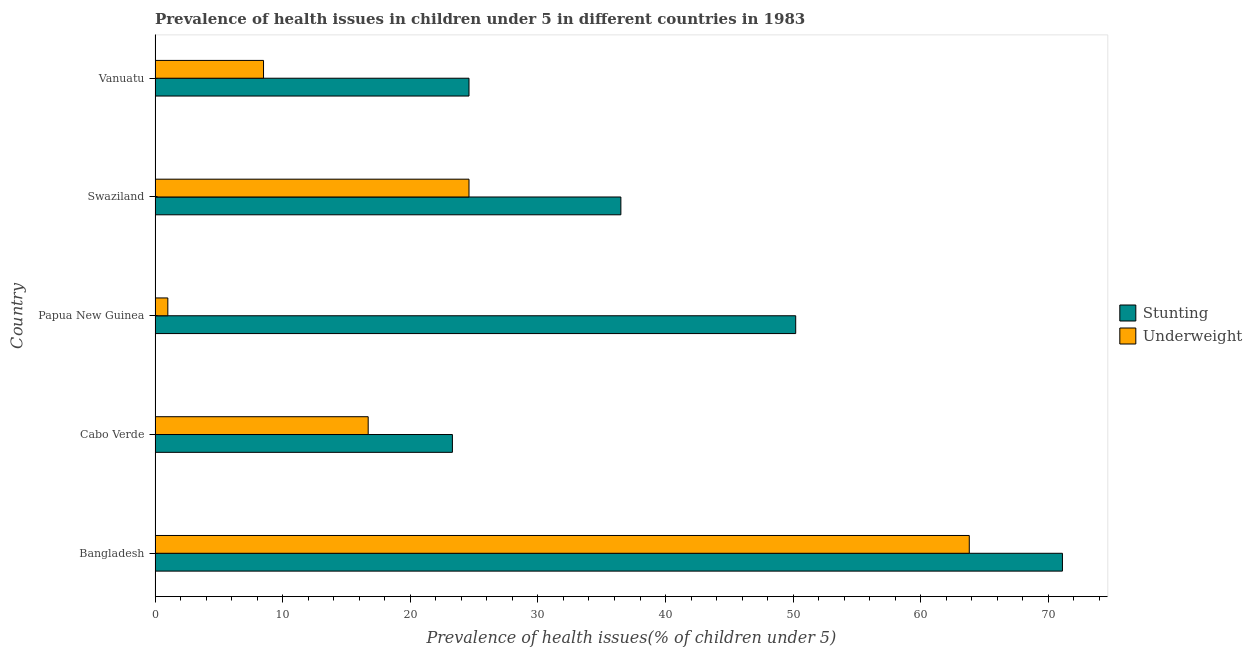How many different coloured bars are there?
Provide a short and direct response. 2. Are the number of bars per tick equal to the number of legend labels?
Make the answer very short. Yes. How many bars are there on the 4th tick from the bottom?
Make the answer very short. 2. What is the label of the 3rd group of bars from the top?
Provide a succinct answer. Papua New Guinea. What is the percentage of stunted children in Vanuatu?
Provide a succinct answer. 24.6. Across all countries, what is the maximum percentage of stunted children?
Your answer should be very brief. 71.1. Across all countries, what is the minimum percentage of stunted children?
Give a very brief answer. 23.3. In which country was the percentage of stunted children maximum?
Give a very brief answer. Bangladesh. In which country was the percentage of underweight children minimum?
Offer a very short reply. Papua New Guinea. What is the total percentage of stunted children in the graph?
Your answer should be very brief. 205.7. What is the difference between the percentage of underweight children in Bangladesh and that in Papua New Guinea?
Provide a short and direct response. 62.8. What is the difference between the percentage of stunted children in Swaziland and the percentage of underweight children in Cabo Verde?
Offer a terse response. 19.8. What is the average percentage of stunted children per country?
Your answer should be very brief. 41.14. What is the ratio of the percentage of stunted children in Bangladesh to that in Vanuatu?
Provide a short and direct response. 2.89. What is the difference between the highest and the second highest percentage of stunted children?
Make the answer very short. 20.9. What is the difference between the highest and the lowest percentage of underweight children?
Give a very brief answer. 62.8. What does the 1st bar from the top in Cabo Verde represents?
Give a very brief answer. Underweight. What does the 2nd bar from the bottom in Cabo Verde represents?
Give a very brief answer. Underweight. Does the graph contain any zero values?
Give a very brief answer. No. Does the graph contain grids?
Ensure brevity in your answer.  No. Where does the legend appear in the graph?
Provide a short and direct response. Center right. How many legend labels are there?
Provide a succinct answer. 2. What is the title of the graph?
Provide a short and direct response. Prevalence of health issues in children under 5 in different countries in 1983. Does "Birth rate" appear as one of the legend labels in the graph?
Ensure brevity in your answer.  No. What is the label or title of the X-axis?
Your answer should be compact. Prevalence of health issues(% of children under 5). What is the Prevalence of health issues(% of children under 5) in Stunting in Bangladesh?
Provide a succinct answer. 71.1. What is the Prevalence of health issues(% of children under 5) in Underweight in Bangladesh?
Keep it short and to the point. 63.8. What is the Prevalence of health issues(% of children under 5) in Stunting in Cabo Verde?
Provide a short and direct response. 23.3. What is the Prevalence of health issues(% of children under 5) in Underweight in Cabo Verde?
Offer a very short reply. 16.7. What is the Prevalence of health issues(% of children under 5) of Stunting in Papua New Guinea?
Give a very brief answer. 50.2. What is the Prevalence of health issues(% of children under 5) in Stunting in Swaziland?
Provide a short and direct response. 36.5. What is the Prevalence of health issues(% of children under 5) in Underweight in Swaziland?
Provide a succinct answer. 24.6. What is the Prevalence of health issues(% of children under 5) of Stunting in Vanuatu?
Keep it short and to the point. 24.6. Across all countries, what is the maximum Prevalence of health issues(% of children under 5) in Stunting?
Provide a succinct answer. 71.1. Across all countries, what is the maximum Prevalence of health issues(% of children under 5) of Underweight?
Keep it short and to the point. 63.8. Across all countries, what is the minimum Prevalence of health issues(% of children under 5) in Stunting?
Provide a succinct answer. 23.3. Across all countries, what is the minimum Prevalence of health issues(% of children under 5) in Underweight?
Ensure brevity in your answer.  1. What is the total Prevalence of health issues(% of children under 5) in Stunting in the graph?
Offer a terse response. 205.7. What is the total Prevalence of health issues(% of children under 5) of Underweight in the graph?
Keep it short and to the point. 114.6. What is the difference between the Prevalence of health issues(% of children under 5) of Stunting in Bangladesh and that in Cabo Verde?
Provide a succinct answer. 47.8. What is the difference between the Prevalence of health issues(% of children under 5) in Underweight in Bangladesh and that in Cabo Verde?
Give a very brief answer. 47.1. What is the difference between the Prevalence of health issues(% of children under 5) of Stunting in Bangladesh and that in Papua New Guinea?
Provide a succinct answer. 20.9. What is the difference between the Prevalence of health issues(% of children under 5) of Underweight in Bangladesh and that in Papua New Guinea?
Offer a very short reply. 62.8. What is the difference between the Prevalence of health issues(% of children under 5) of Stunting in Bangladesh and that in Swaziland?
Your answer should be compact. 34.6. What is the difference between the Prevalence of health issues(% of children under 5) of Underweight in Bangladesh and that in Swaziland?
Provide a succinct answer. 39.2. What is the difference between the Prevalence of health issues(% of children under 5) of Stunting in Bangladesh and that in Vanuatu?
Your response must be concise. 46.5. What is the difference between the Prevalence of health issues(% of children under 5) in Underweight in Bangladesh and that in Vanuatu?
Offer a very short reply. 55.3. What is the difference between the Prevalence of health issues(% of children under 5) in Stunting in Cabo Verde and that in Papua New Guinea?
Make the answer very short. -26.9. What is the difference between the Prevalence of health issues(% of children under 5) of Underweight in Cabo Verde and that in Papua New Guinea?
Ensure brevity in your answer.  15.7. What is the difference between the Prevalence of health issues(% of children under 5) in Stunting in Cabo Verde and that in Swaziland?
Ensure brevity in your answer.  -13.2. What is the difference between the Prevalence of health issues(% of children under 5) of Underweight in Cabo Verde and that in Swaziland?
Your answer should be compact. -7.9. What is the difference between the Prevalence of health issues(% of children under 5) of Stunting in Cabo Verde and that in Vanuatu?
Offer a very short reply. -1.3. What is the difference between the Prevalence of health issues(% of children under 5) of Underweight in Papua New Guinea and that in Swaziland?
Provide a short and direct response. -23.6. What is the difference between the Prevalence of health issues(% of children under 5) in Stunting in Papua New Guinea and that in Vanuatu?
Your answer should be compact. 25.6. What is the difference between the Prevalence of health issues(% of children under 5) of Underweight in Papua New Guinea and that in Vanuatu?
Your answer should be compact. -7.5. What is the difference between the Prevalence of health issues(% of children under 5) of Stunting in Swaziland and that in Vanuatu?
Offer a very short reply. 11.9. What is the difference between the Prevalence of health issues(% of children under 5) of Underweight in Swaziland and that in Vanuatu?
Give a very brief answer. 16.1. What is the difference between the Prevalence of health issues(% of children under 5) of Stunting in Bangladesh and the Prevalence of health issues(% of children under 5) of Underweight in Cabo Verde?
Keep it short and to the point. 54.4. What is the difference between the Prevalence of health issues(% of children under 5) of Stunting in Bangladesh and the Prevalence of health issues(% of children under 5) of Underweight in Papua New Guinea?
Offer a terse response. 70.1. What is the difference between the Prevalence of health issues(% of children under 5) of Stunting in Bangladesh and the Prevalence of health issues(% of children under 5) of Underweight in Swaziland?
Offer a very short reply. 46.5. What is the difference between the Prevalence of health issues(% of children under 5) in Stunting in Bangladesh and the Prevalence of health issues(% of children under 5) in Underweight in Vanuatu?
Ensure brevity in your answer.  62.6. What is the difference between the Prevalence of health issues(% of children under 5) in Stunting in Cabo Verde and the Prevalence of health issues(% of children under 5) in Underweight in Papua New Guinea?
Ensure brevity in your answer.  22.3. What is the difference between the Prevalence of health issues(% of children under 5) in Stunting in Papua New Guinea and the Prevalence of health issues(% of children under 5) in Underweight in Swaziland?
Keep it short and to the point. 25.6. What is the difference between the Prevalence of health issues(% of children under 5) of Stunting in Papua New Guinea and the Prevalence of health issues(% of children under 5) of Underweight in Vanuatu?
Provide a succinct answer. 41.7. What is the average Prevalence of health issues(% of children under 5) of Stunting per country?
Your answer should be compact. 41.14. What is the average Prevalence of health issues(% of children under 5) of Underweight per country?
Offer a very short reply. 22.92. What is the difference between the Prevalence of health issues(% of children under 5) of Stunting and Prevalence of health issues(% of children under 5) of Underweight in Cabo Verde?
Offer a terse response. 6.6. What is the difference between the Prevalence of health issues(% of children under 5) of Stunting and Prevalence of health issues(% of children under 5) of Underweight in Papua New Guinea?
Your answer should be compact. 49.2. What is the difference between the Prevalence of health issues(% of children under 5) in Stunting and Prevalence of health issues(% of children under 5) in Underweight in Vanuatu?
Offer a terse response. 16.1. What is the ratio of the Prevalence of health issues(% of children under 5) of Stunting in Bangladesh to that in Cabo Verde?
Keep it short and to the point. 3.05. What is the ratio of the Prevalence of health issues(% of children under 5) of Underweight in Bangladesh to that in Cabo Verde?
Ensure brevity in your answer.  3.82. What is the ratio of the Prevalence of health issues(% of children under 5) of Stunting in Bangladesh to that in Papua New Guinea?
Provide a succinct answer. 1.42. What is the ratio of the Prevalence of health issues(% of children under 5) of Underweight in Bangladesh to that in Papua New Guinea?
Your answer should be compact. 63.8. What is the ratio of the Prevalence of health issues(% of children under 5) in Stunting in Bangladesh to that in Swaziland?
Keep it short and to the point. 1.95. What is the ratio of the Prevalence of health issues(% of children under 5) of Underweight in Bangladesh to that in Swaziland?
Keep it short and to the point. 2.59. What is the ratio of the Prevalence of health issues(% of children under 5) of Stunting in Bangladesh to that in Vanuatu?
Keep it short and to the point. 2.89. What is the ratio of the Prevalence of health issues(% of children under 5) in Underweight in Bangladesh to that in Vanuatu?
Give a very brief answer. 7.51. What is the ratio of the Prevalence of health issues(% of children under 5) in Stunting in Cabo Verde to that in Papua New Guinea?
Offer a terse response. 0.46. What is the ratio of the Prevalence of health issues(% of children under 5) in Underweight in Cabo Verde to that in Papua New Guinea?
Offer a terse response. 16.7. What is the ratio of the Prevalence of health issues(% of children under 5) of Stunting in Cabo Verde to that in Swaziland?
Your answer should be very brief. 0.64. What is the ratio of the Prevalence of health issues(% of children under 5) in Underweight in Cabo Verde to that in Swaziland?
Make the answer very short. 0.68. What is the ratio of the Prevalence of health issues(% of children under 5) in Stunting in Cabo Verde to that in Vanuatu?
Offer a terse response. 0.95. What is the ratio of the Prevalence of health issues(% of children under 5) of Underweight in Cabo Verde to that in Vanuatu?
Give a very brief answer. 1.96. What is the ratio of the Prevalence of health issues(% of children under 5) in Stunting in Papua New Guinea to that in Swaziland?
Your response must be concise. 1.38. What is the ratio of the Prevalence of health issues(% of children under 5) of Underweight in Papua New Guinea to that in Swaziland?
Your answer should be very brief. 0.04. What is the ratio of the Prevalence of health issues(% of children under 5) in Stunting in Papua New Guinea to that in Vanuatu?
Keep it short and to the point. 2.04. What is the ratio of the Prevalence of health issues(% of children under 5) of Underweight in Papua New Guinea to that in Vanuatu?
Your response must be concise. 0.12. What is the ratio of the Prevalence of health issues(% of children under 5) of Stunting in Swaziland to that in Vanuatu?
Keep it short and to the point. 1.48. What is the ratio of the Prevalence of health issues(% of children under 5) of Underweight in Swaziland to that in Vanuatu?
Make the answer very short. 2.89. What is the difference between the highest and the second highest Prevalence of health issues(% of children under 5) in Stunting?
Your answer should be very brief. 20.9. What is the difference between the highest and the second highest Prevalence of health issues(% of children under 5) in Underweight?
Offer a very short reply. 39.2. What is the difference between the highest and the lowest Prevalence of health issues(% of children under 5) of Stunting?
Ensure brevity in your answer.  47.8. What is the difference between the highest and the lowest Prevalence of health issues(% of children under 5) in Underweight?
Ensure brevity in your answer.  62.8. 